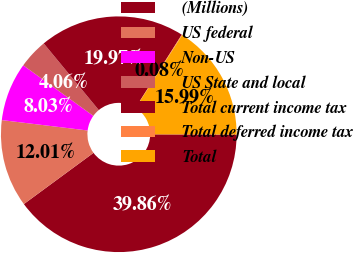<chart> <loc_0><loc_0><loc_500><loc_500><pie_chart><fcel>(Millions)<fcel>US federal<fcel>Non-US<fcel>US State and local<fcel>Total current income tax<fcel>Total deferred income tax<fcel>Total<nl><fcel>39.86%<fcel>12.01%<fcel>8.03%<fcel>4.06%<fcel>19.97%<fcel>0.08%<fcel>15.99%<nl></chart> 